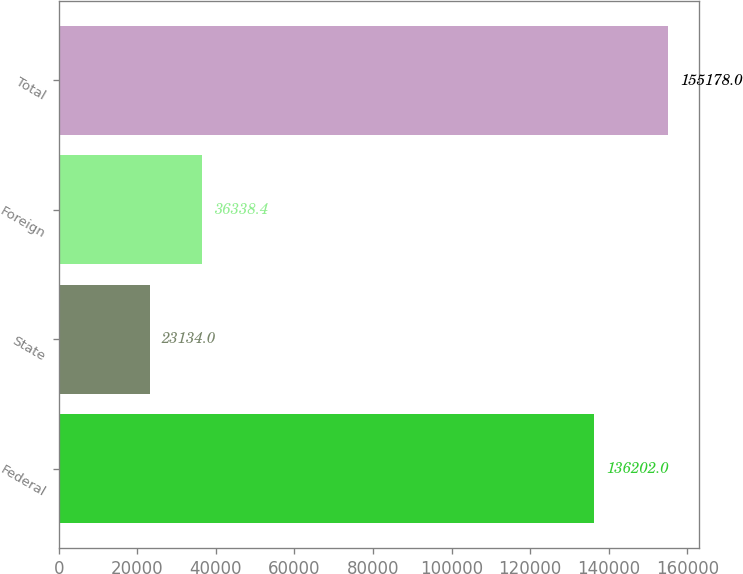<chart> <loc_0><loc_0><loc_500><loc_500><bar_chart><fcel>Federal<fcel>State<fcel>Foreign<fcel>Total<nl><fcel>136202<fcel>23134<fcel>36338.4<fcel>155178<nl></chart> 